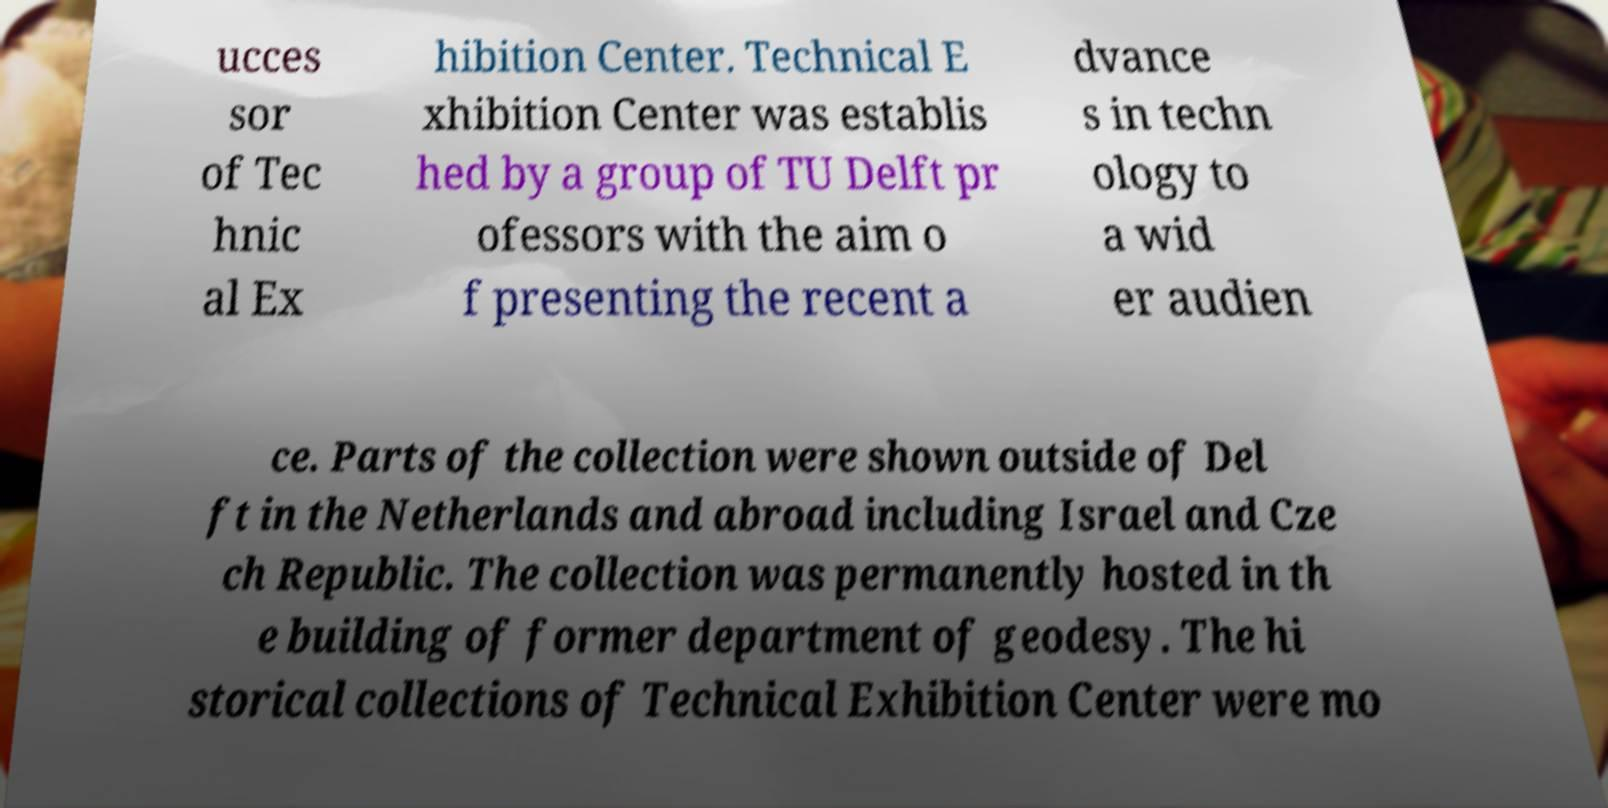What messages or text are displayed in this image? I need them in a readable, typed format. ucces sor of Tec hnic al Ex hibition Center. Technical E xhibition Center was establis hed by a group of TU Delft pr ofessors with the aim o f presenting the recent a dvance s in techn ology to a wid er audien ce. Parts of the collection were shown outside of Del ft in the Netherlands and abroad including Israel and Cze ch Republic. The collection was permanently hosted in th e building of former department of geodesy. The hi storical collections of Technical Exhibition Center were mo 